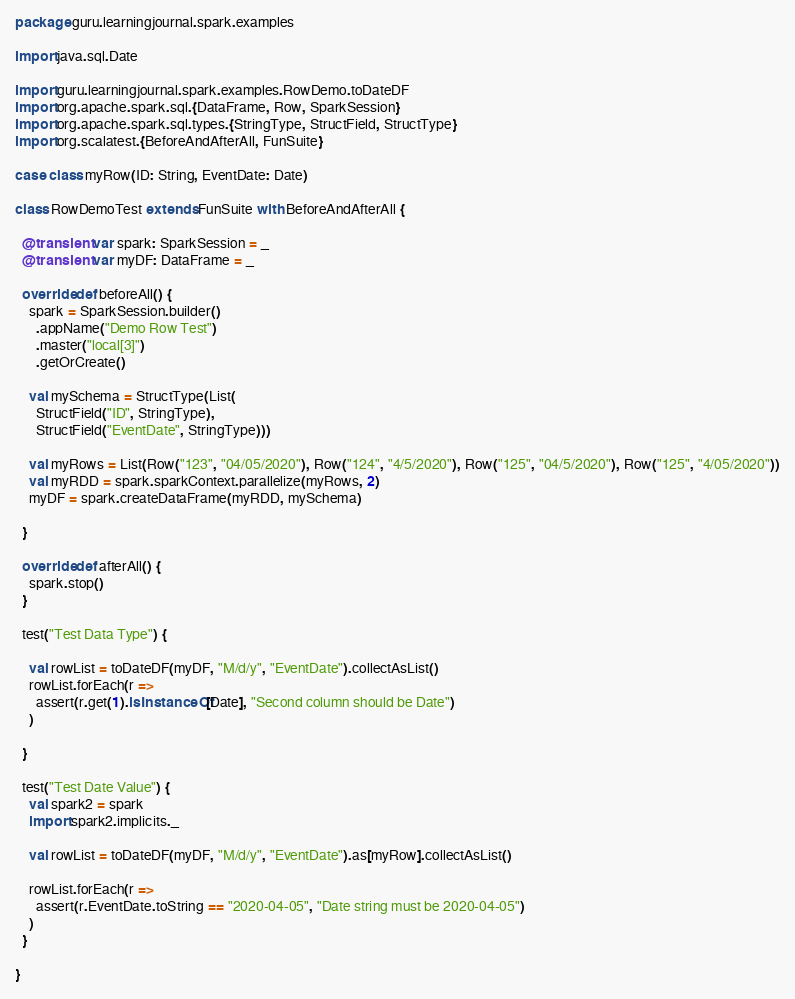Convert code to text. <code><loc_0><loc_0><loc_500><loc_500><_Scala_>package guru.learningjournal.spark.examples

import java.sql.Date

import guru.learningjournal.spark.examples.RowDemo.toDateDF
import org.apache.spark.sql.{DataFrame, Row, SparkSession}
import org.apache.spark.sql.types.{StringType, StructField, StructType}
import org.scalatest.{BeforeAndAfterAll, FunSuite}

case class myRow(ID: String, EventDate: Date)

class RowDemoTest extends FunSuite with BeforeAndAfterAll {

  @transient var spark: SparkSession = _
  @transient var myDF: DataFrame = _

  override def beforeAll() {
    spark = SparkSession.builder()
      .appName("Demo Row Test")
      .master("local[3]")
      .getOrCreate()

    val mySchema = StructType(List(
      StructField("ID", StringType),
      StructField("EventDate", StringType)))

    val myRows = List(Row("123", "04/05/2020"), Row("124", "4/5/2020"), Row("125", "04/5/2020"), Row("125", "4/05/2020"))
    val myRDD = spark.sparkContext.parallelize(myRows, 2)
    myDF = spark.createDataFrame(myRDD, mySchema)

  }

  override def afterAll() {
    spark.stop()
  }

  test("Test Data Type") {

    val rowList = toDateDF(myDF, "M/d/y", "EventDate").collectAsList()
    rowList.forEach(r =>
      assert(r.get(1).isInstanceOf[Date], "Second column should be Date")
    )

  }

  test("Test Date Value") {
    val spark2 = spark
    import spark2.implicits._

    val rowList = toDateDF(myDF, "M/d/y", "EventDate").as[myRow].collectAsList()

    rowList.forEach(r =>
      assert(r.EventDate.toString == "2020-04-05", "Date string must be 2020-04-05")
    )
  }

}
</code> 